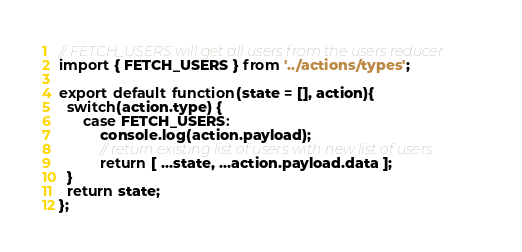Convert code to text. <code><loc_0><loc_0><loc_500><loc_500><_JavaScript_>// FETCH_USERS will get all users from the users reducer
import { FETCH_USERS } from '../actions/types';

export default function(state = [], action){
  switch(action.type) {
      case FETCH_USERS:
          console.log(action.payload);
          // return existing list of users with new list of users
          return [ ...state, ...action.payload.data ];
  }
  return state;
};</code> 